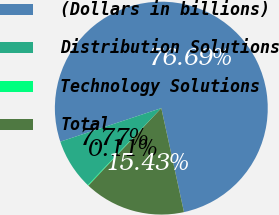Convert chart to OTSL. <chart><loc_0><loc_0><loc_500><loc_500><pie_chart><fcel>(Dollars in billions)<fcel>Distribution Solutions<fcel>Technology Solutions<fcel>Total<nl><fcel>76.69%<fcel>7.77%<fcel>0.11%<fcel>15.43%<nl></chart> 